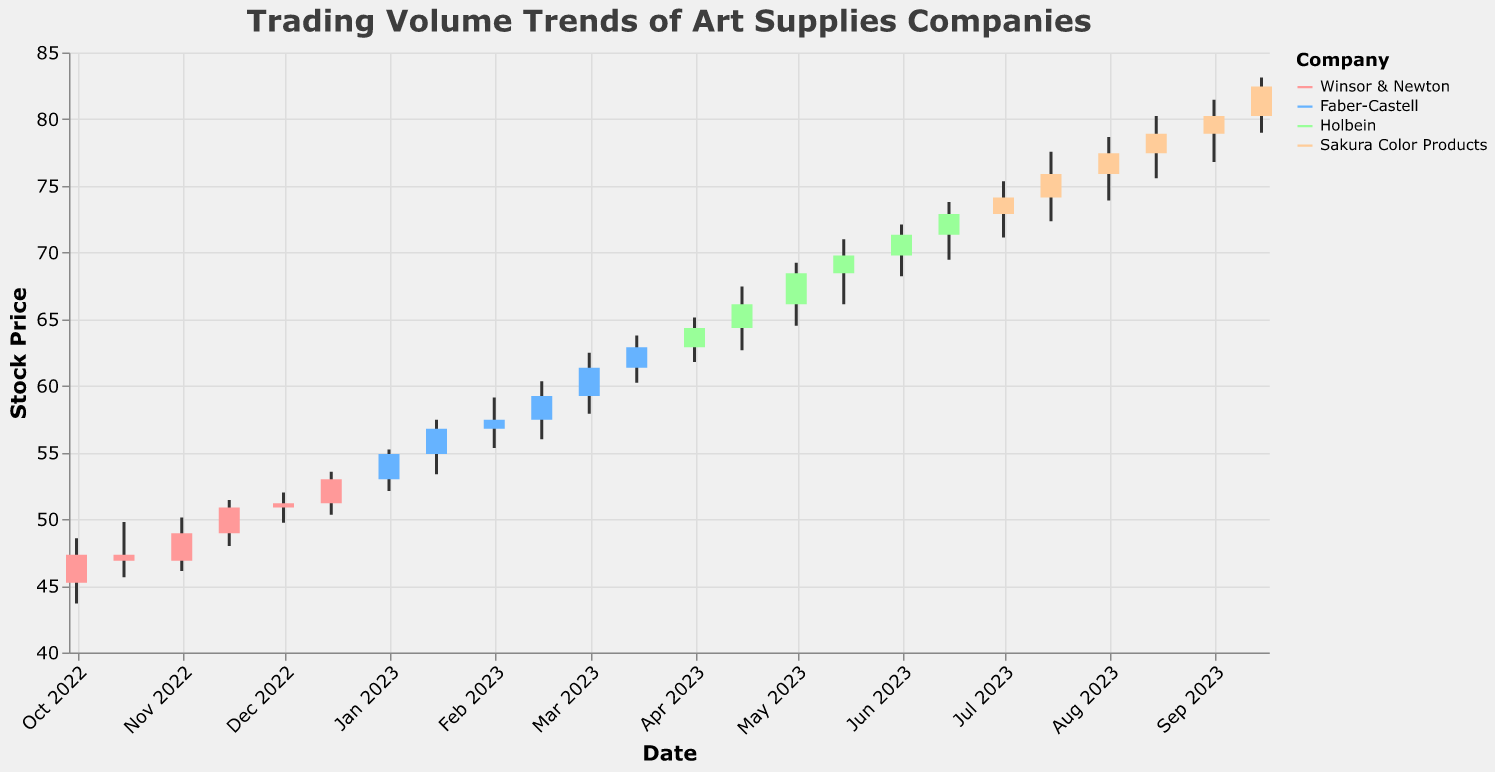What is the main title of the figure? The main title is displayed at the top of the figure in a larger font. It reads "Trading Volume Trends of Art Supplies Companies."
Answer: Trading Volume Trends of Art Supplies Companies What companies are represented in the figure by different colors? The legend in the figure uses colors to represent four companies: Winsor & Newton, Faber-Castell, Holbein, and Sakura Color Products.
Answer: Winsor & Newton, Faber-Castell, Holbein, Sakura Color Products Which company had the lowest trading volume during the period covered in the figure? By observing the height of the bar indicating trading volume, Winsor & Newton had the lowest trading volume, which is 1,300,000 on 2022-10-15.
Answer: Winsor & Newton Between Faber-Castell and Sakura Color Products, which company had a higher trading volume on 2023-02-01, and what was the volume? The bars for trading volume reflect that Faber-Castell had a volume of 2,200,000 on 2023-02-01. On the same date, Sakura Color Products was not listed, so Faber-Castell had a higher volume.
Answer: Faber-Castell, 2,200,000 How does the trading volume of Holbein compare between 2023-04-01 and 2023-05-01? By comparing the heights of the bars for these two dates, Holbein's trading volume increased from 2,600,000 on 2023-04-01 to 2,800,000 on 2023-05-01.
Answer: Increased What month had the highest stock price for Sakura Color Products, and what was the price? By finding the highest "High" value for Sakura Color Products, we see the highest price was 83.12 in September 2023.
Answer: September 2023, 83.12 What is the average trading volume for Faber-Castell over the months it is listed? Calculating the average of Faber-Castell volumes: (2000000 + 2100000 + 2200000 + 2300000 + 2400000 + 2500000)/6 = 2250000.
Answer: 2,250,000 Which company's stock price had the highest closing value in the entire period, and what was it? By looking at the Close values, Sakura Color Products had the highest closing value of 82.45 on 2023-09-15.
Answer: Sakura Color Products, 82.45 Did Winsor & Newton experience any decrease in stock price from any opening to closing within the same day? This requires checking if the Open value is greater than the Close value: on 2022-10-15, stock price decreased from 47.34 (Open) to 46.89 (Close).
Answer: Yes What was the highest volume traded by any company, and which company achieved it? The highest volume bar corresponds to 3,700,000 on 2023-09-15 by Sakura Color Products.
Answer: 3,700,000, Sakura Color Products 